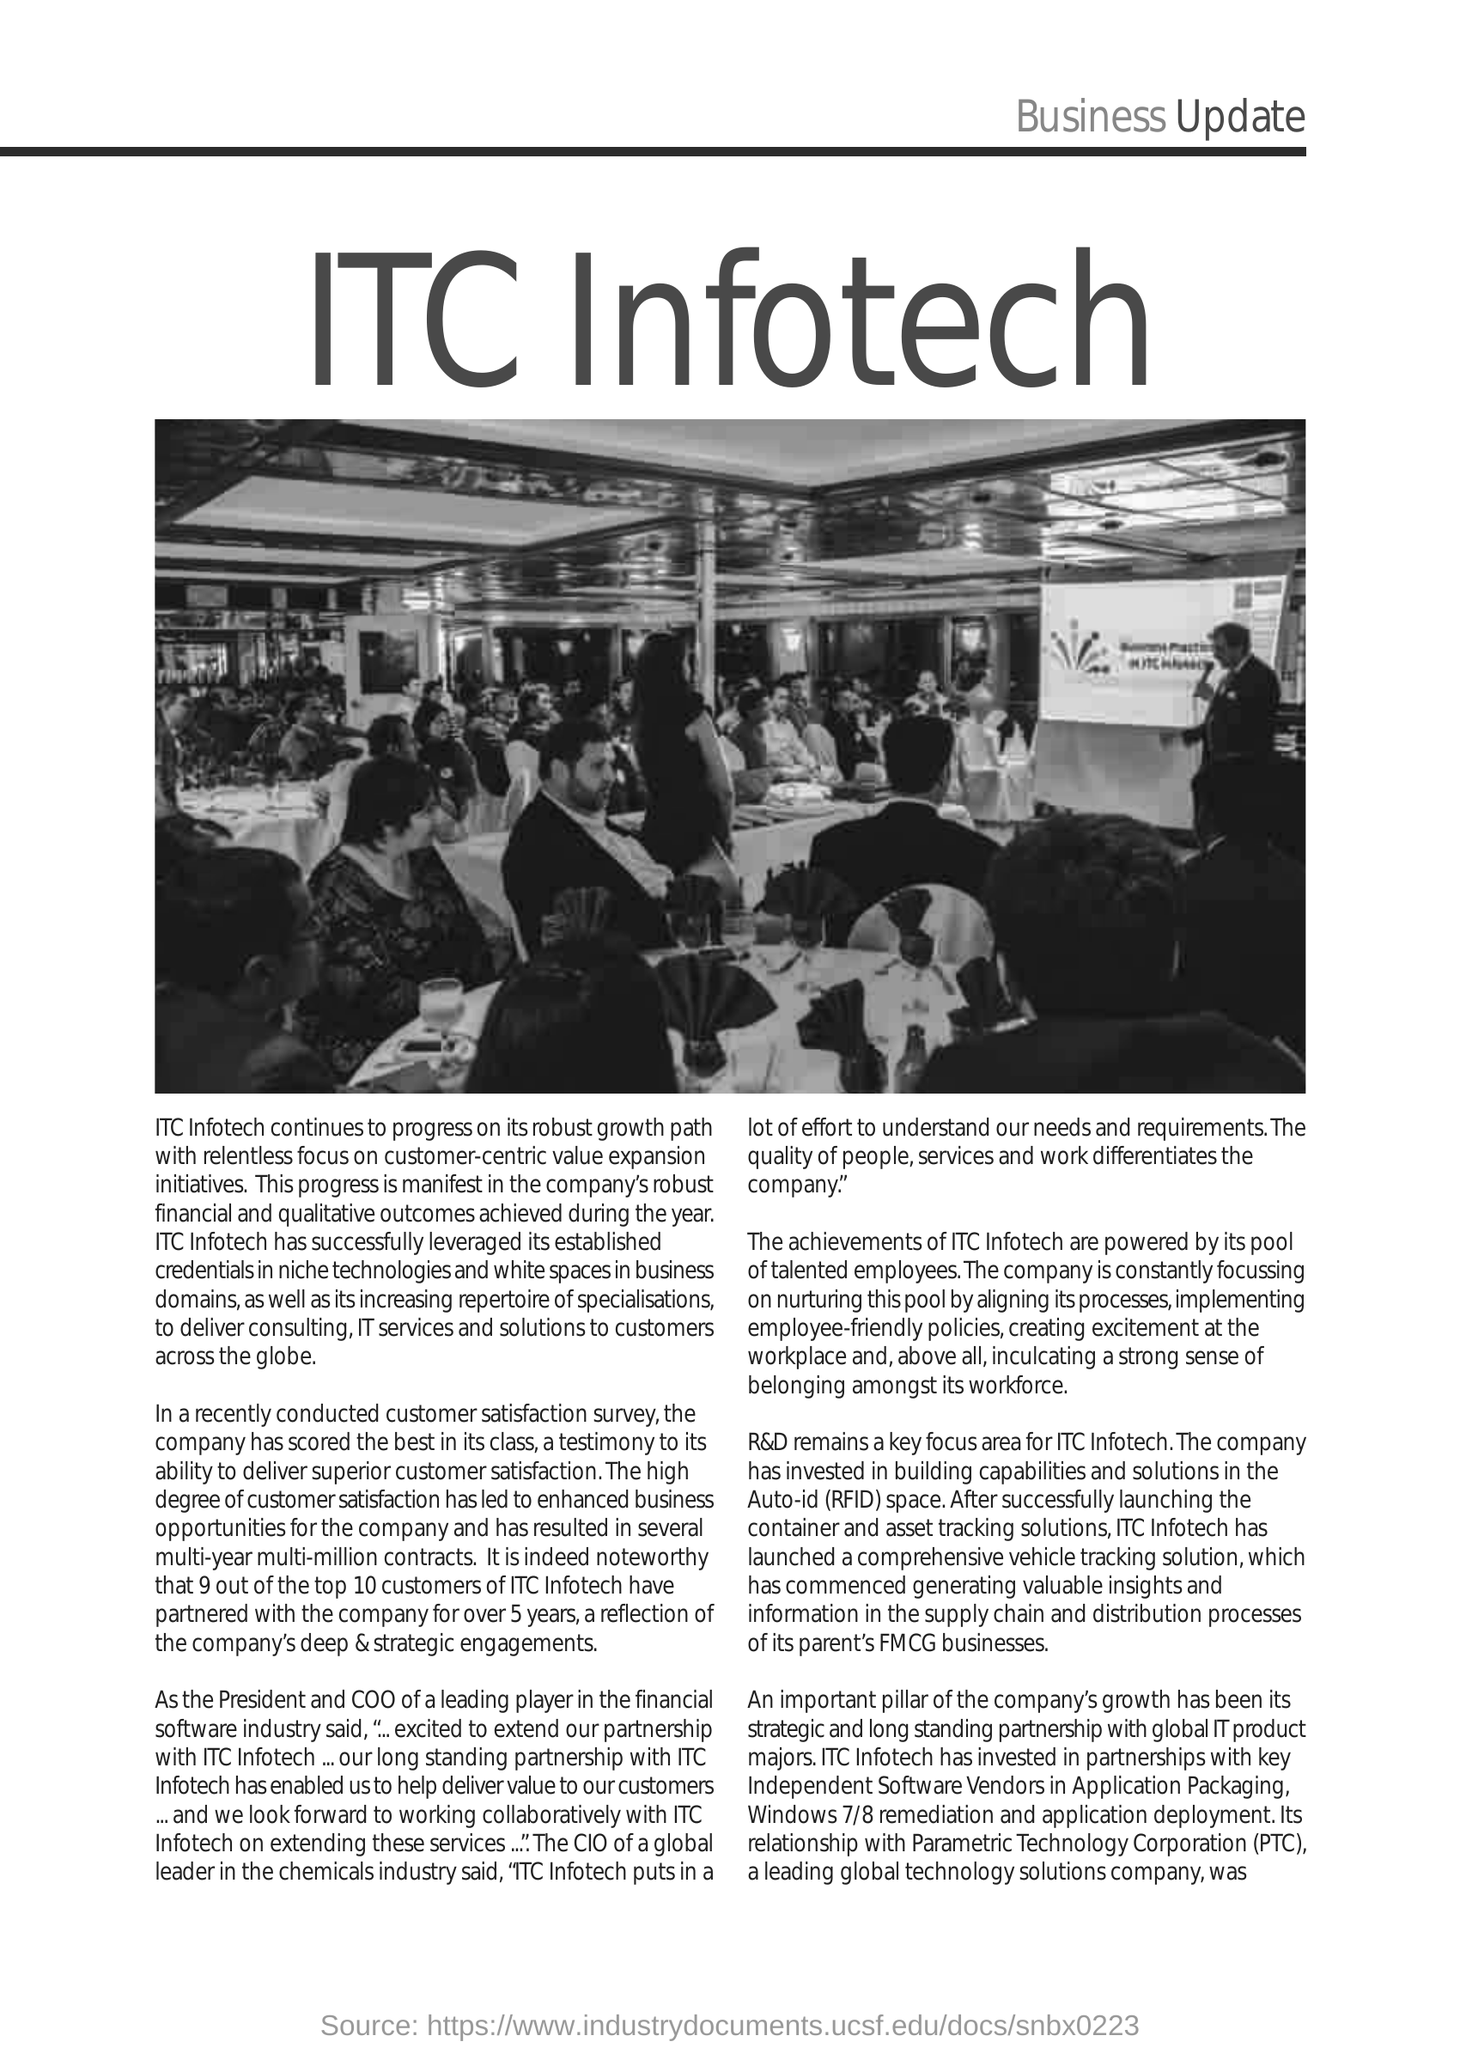What is the Fullform of PTC ?
Give a very brief answer. Parametric Technology Corporation. 